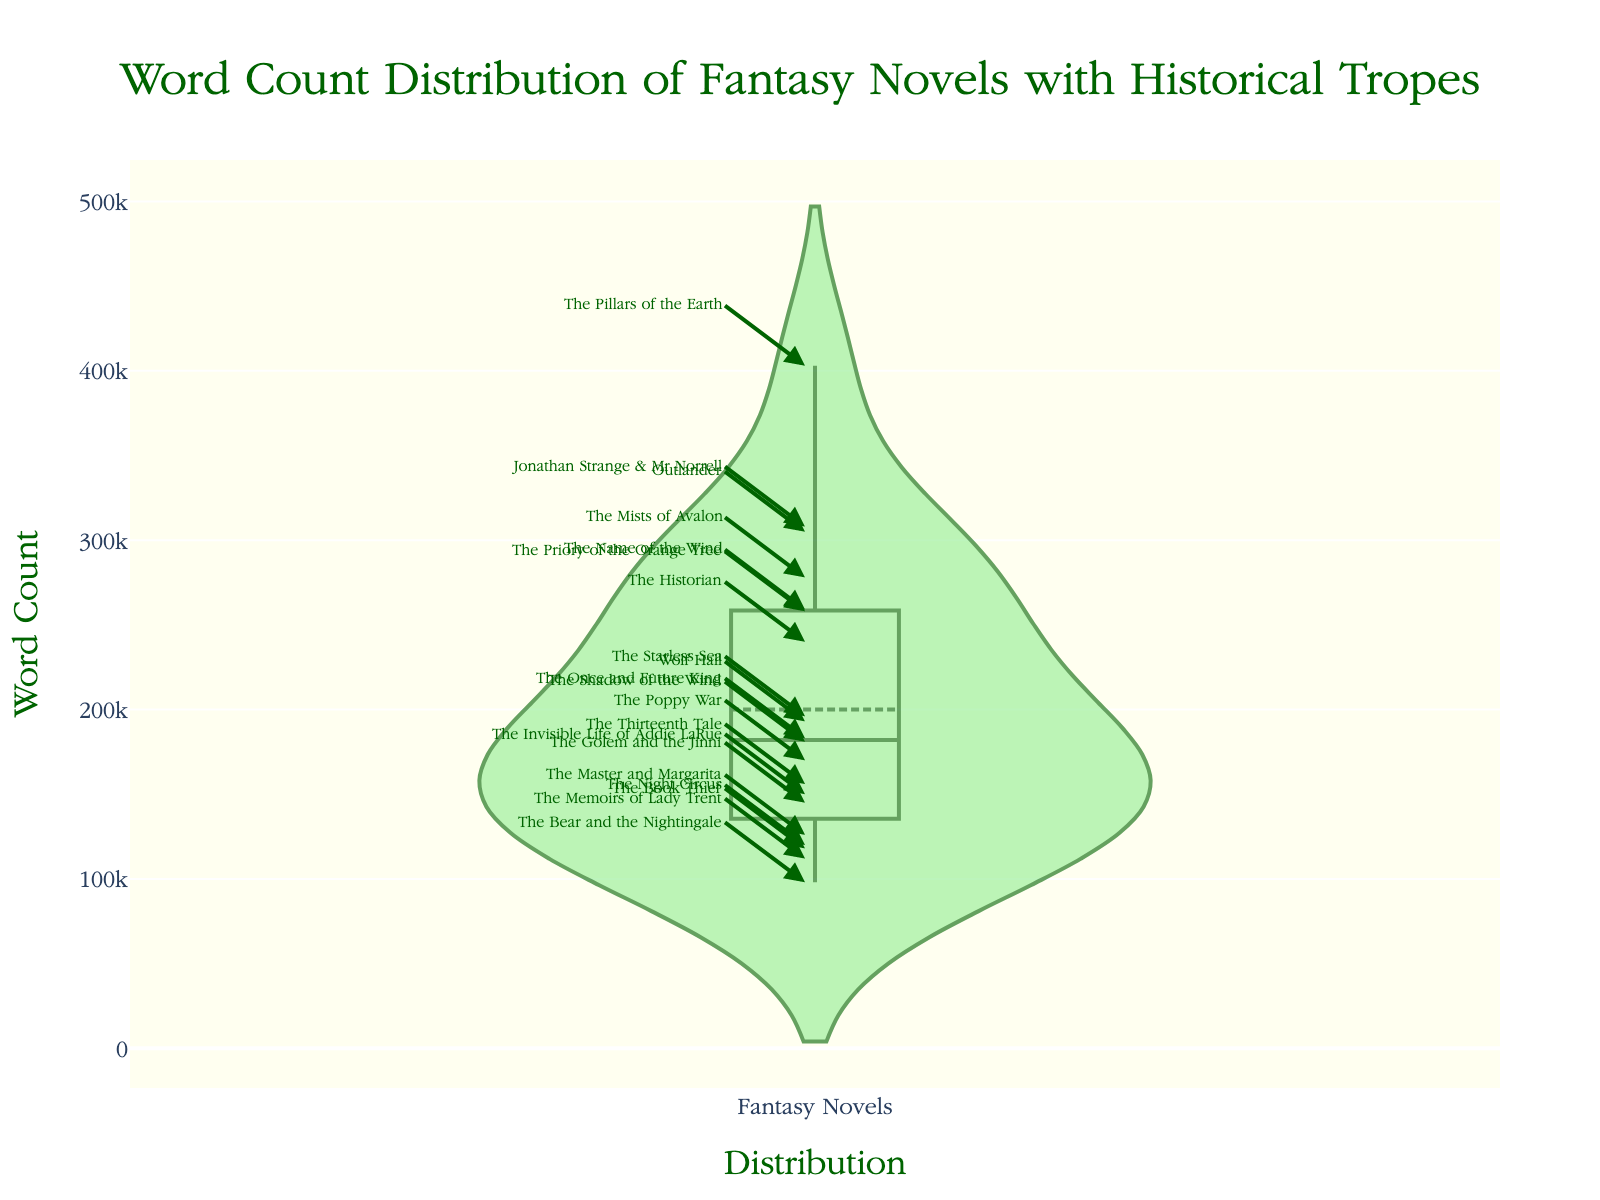What is the title of the plot? The title of the plot is displayed at the top of the figure in large text.
Answer: Word Count Distribution of Fantasy Novels with Historical Tropes How many novels are included in the plot? Each individual marker on the plot represents a novel, and by counting them, we can determine the total number of novels. There are 20 novels
Answer: 20 What is the word count for the novel "Jonathan Strange & Mr Norrell"? Each annotation aligns with the corresponding word count on the y-axis. Locate "Jonathan Strange & Mr Norrell" and read the word count next to it.
Answer: 308000 Which novel has the highest word count? By observing the dataset's highest point on the y-axis and identifying the corresponding annotation, we can find the novel title with the highest word count.
Answer: The Pillars of the Earth What is the word count range of the novels shown in the plot? The range is calculated by subtracting the smallest word count from the largest word count in the dataset. From the plot, it’s clear that the minimum word count is 98,000 and the maximum is 403,000.
Answer: 305,000 What is the approximate median word count in the plot? The median word count is approximately the value that splits the dataset into two halves. Looking at the distribution, it’s around the middle close to a dense region.
Answer: ~183,000 Which novel is represented by a marker located at 150,000 words? Locate the marker aligned with the 150,000 mark on the y-axis and read the annotation next to it.
Answer: The Invisible Life of Addie LaRue Are there more novels with word counts above or below 200,000? Count the number of markers above and below the 200,000 word count line. From visual inspection, more markers are below 200,000.
Answer: Below Does "The Book Thief" have more or fewer words than the average word count of the novels in the plot? First, find the word count of "The Book Thief" which is 118,000. Then, visually approximate the average word count from the density mids. "The Book Thief" has fewer words than this average.
Answer: Fewer What is the average word count of novels in the 200,000-250,000 range? Identify novels falling between 200,000-250,000, sum their word counts and divide by the number of novels. From visual inspection, novels include "The Starless Sea" (196,000), "The Historian" (240,000), and approximately a couple more. Averaging, it's around 241,000.
Answer: ~241,000 